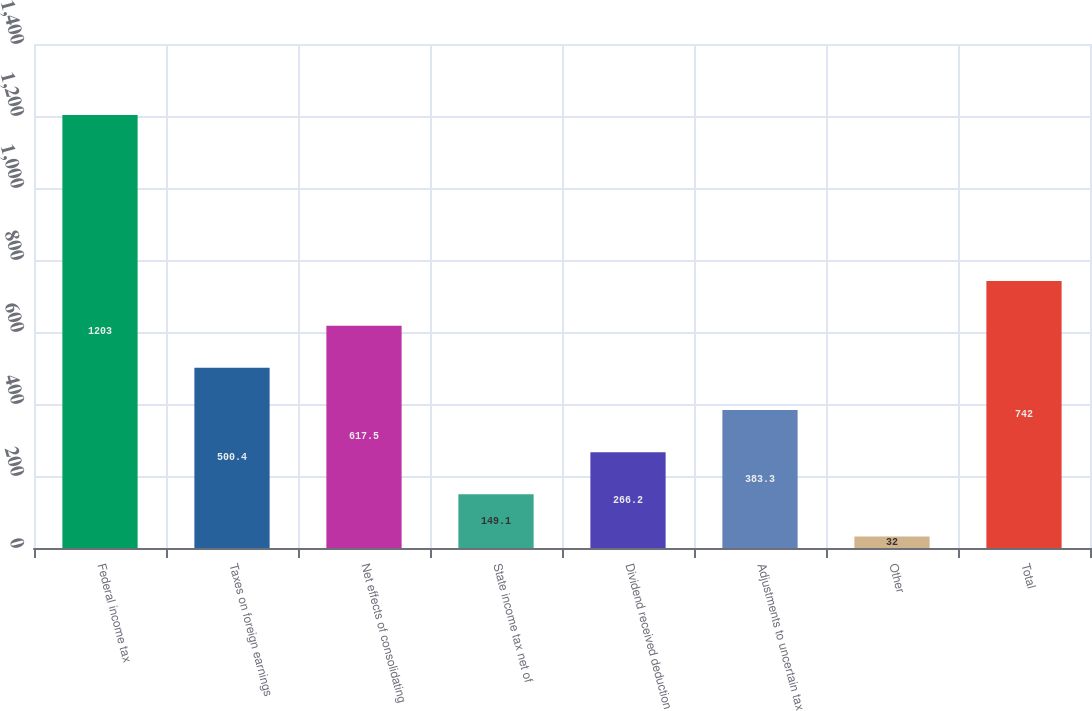Convert chart to OTSL. <chart><loc_0><loc_0><loc_500><loc_500><bar_chart><fcel>Federal income tax<fcel>Taxes on foreign earnings<fcel>Net effects of consolidating<fcel>State income tax net of<fcel>Dividend received deduction<fcel>Adjustments to uncertain tax<fcel>Other<fcel>Total<nl><fcel>1203<fcel>500.4<fcel>617.5<fcel>149.1<fcel>266.2<fcel>383.3<fcel>32<fcel>742<nl></chart> 